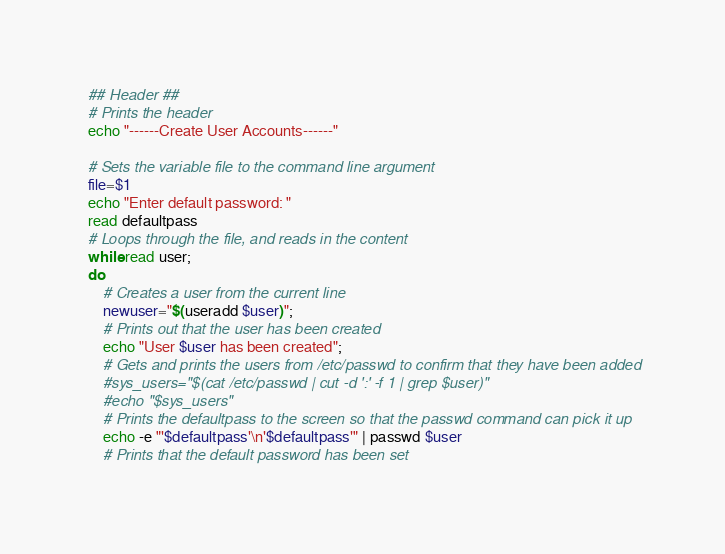<code> <loc_0><loc_0><loc_500><loc_500><_Bash_>
## Header ##
# Prints the header
echo "------Create User Accounts------"

# Sets the variable file to the command line argument
file=$1
echo "Enter default password: "
read defaultpass
# Loops through the file, and reads in the content
while read user;
do
    # Creates a user from the current line
    newuser="$(useradd $user)";
    # Prints out that the user has been created
    echo "User $user has been created";
    # Gets and prints the users from /etc/passwd to confirm that they have been added
    #sys_users="$(cat /etc/passwd | cut -d ':' -f 1 | grep $user)"
    #echo "$sys_users"
    # Prints the defaultpass to the screen so that the passwd command can pick it up
    echo -e "'$defaultpass'\n'$defaultpass'" | passwd $user
    # Prints that the default password has been set</code> 